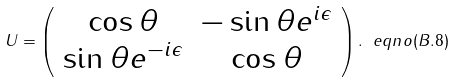<formula> <loc_0><loc_0><loc_500><loc_500>U = \left ( \begin{array} { c c } { { \cos { \theta } } } & { { - \sin { \theta } e ^ { i { \epsilon } } } } \\ { { \sin { \theta } e ^ { - i { \epsilon } } } } & { { \cos { \theta } } } \end{array} \right ) . \ e q n o ( B . 8 )</formula> 